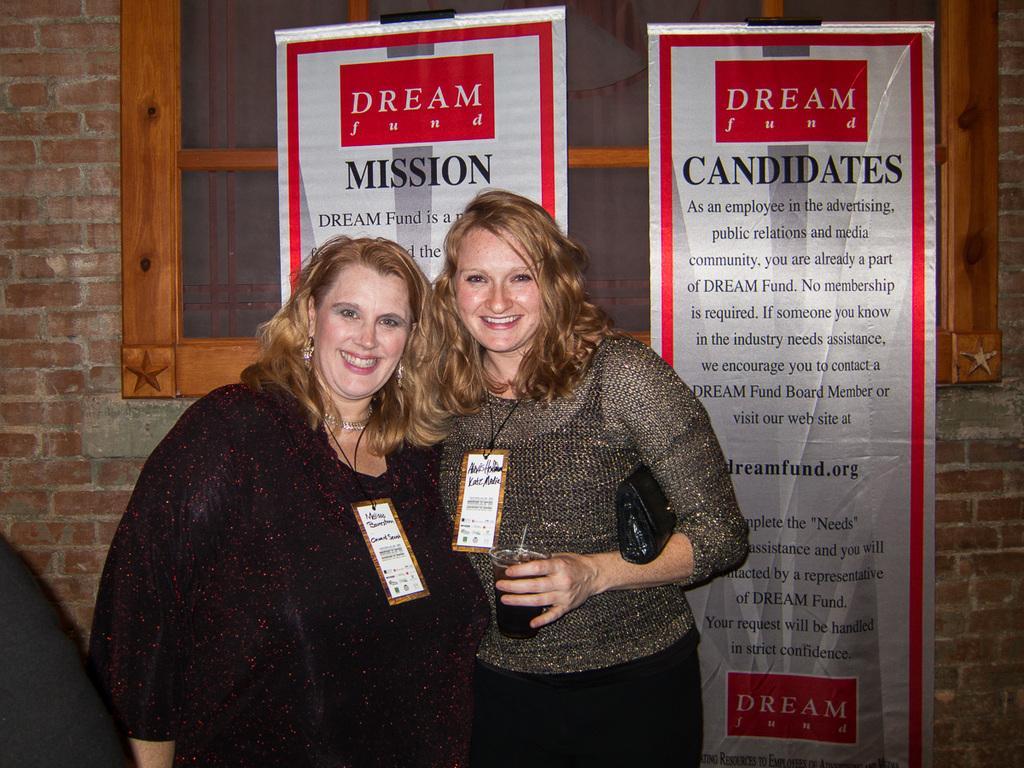In one or two sentences, can you explain what this image depicts? In the middle of this image, there are two women, wearing badges, smiling and standing. One of them is holding a glass, which is filled with drink. In the background, there are two banners arranged, and there is a brick wall of a building, which is having a window. 